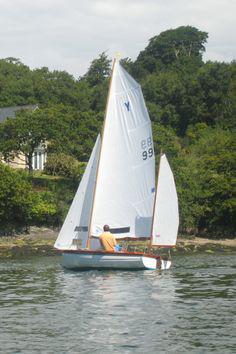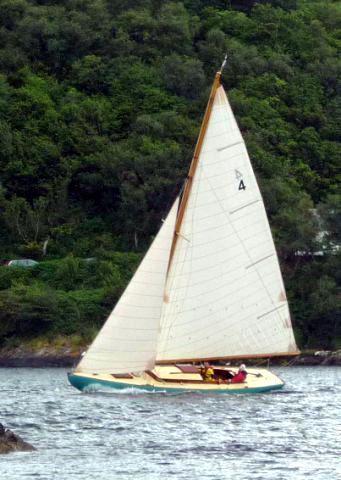The first image is the image on the left, the second image is the image on the right. For the images shown, is this caption "There is a single boat on the water with exactly 3 white sails open, that are being used to move the boat." true? Answer yes or no. Yes. The first image is the image on the left, the second image is the image on the right. For the images shown, is this caption "in at least one image there is a single  boat with 3 sails" true? Answer yes or no. Yes. 